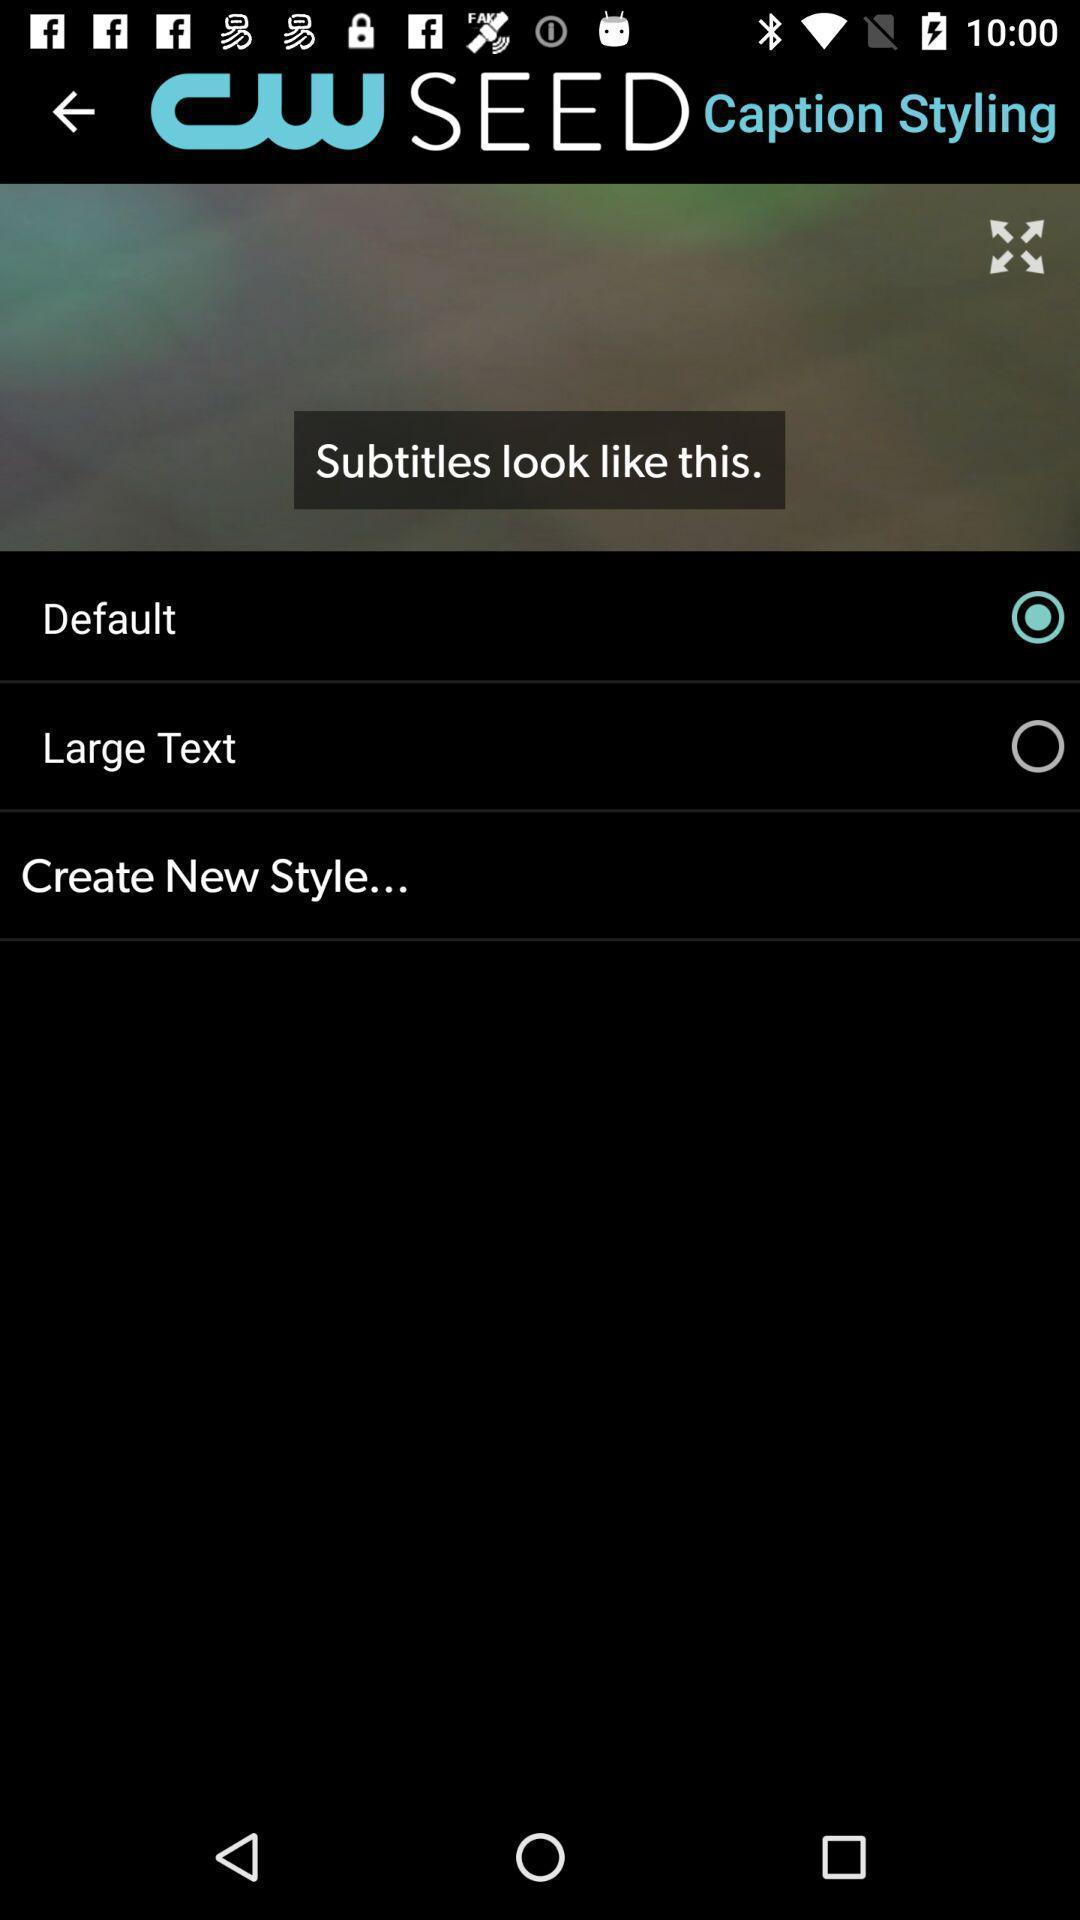Describe the key features of this screenshot. Screen displaying the font size options. 